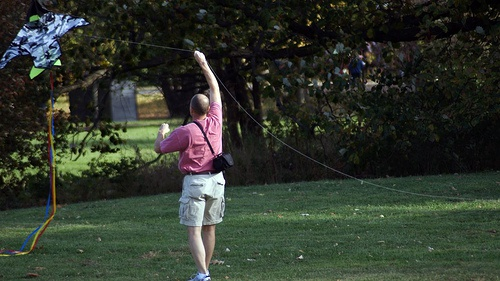Describe the objects in this image and their specific colors. I can see people in black, lightgray, gray, darkgray, and lightpink tones, kite in black, gray, darkgray, and navy tones, kite in black, maroon, olive, and navy tones, and handbag in black, gray, purple, and lightpink tones in this image. 